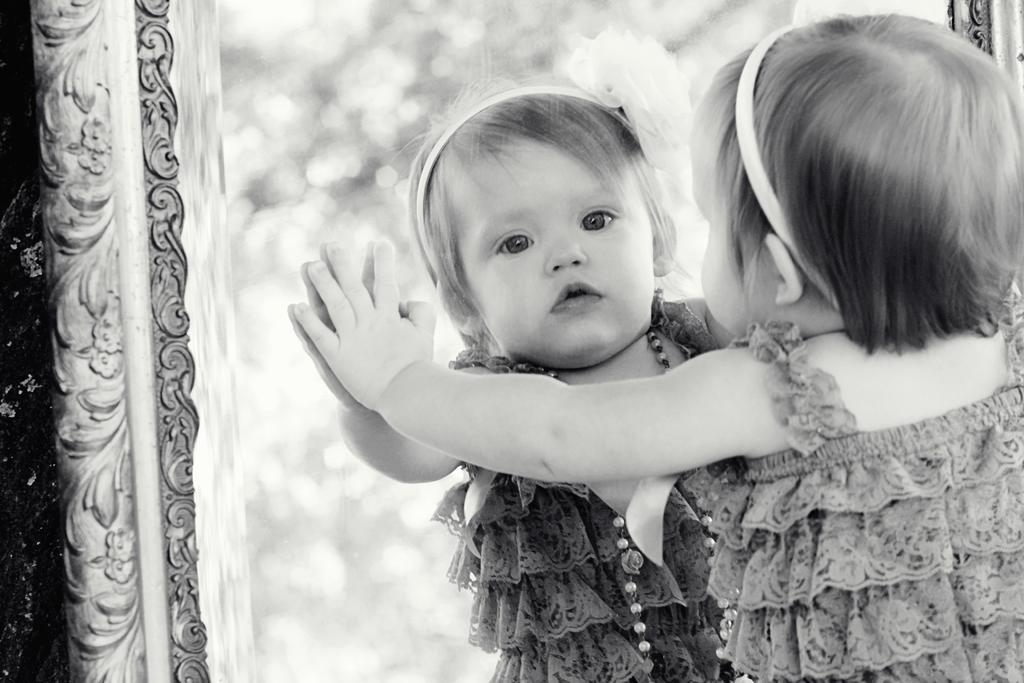Who is the main subject in the image? There is a girl in the image. What is the girl doing in the image? The girl is standing in front of a mirror. What type of pail is the girl using to skate in the image? There is no pail or skating activity present in the image. 